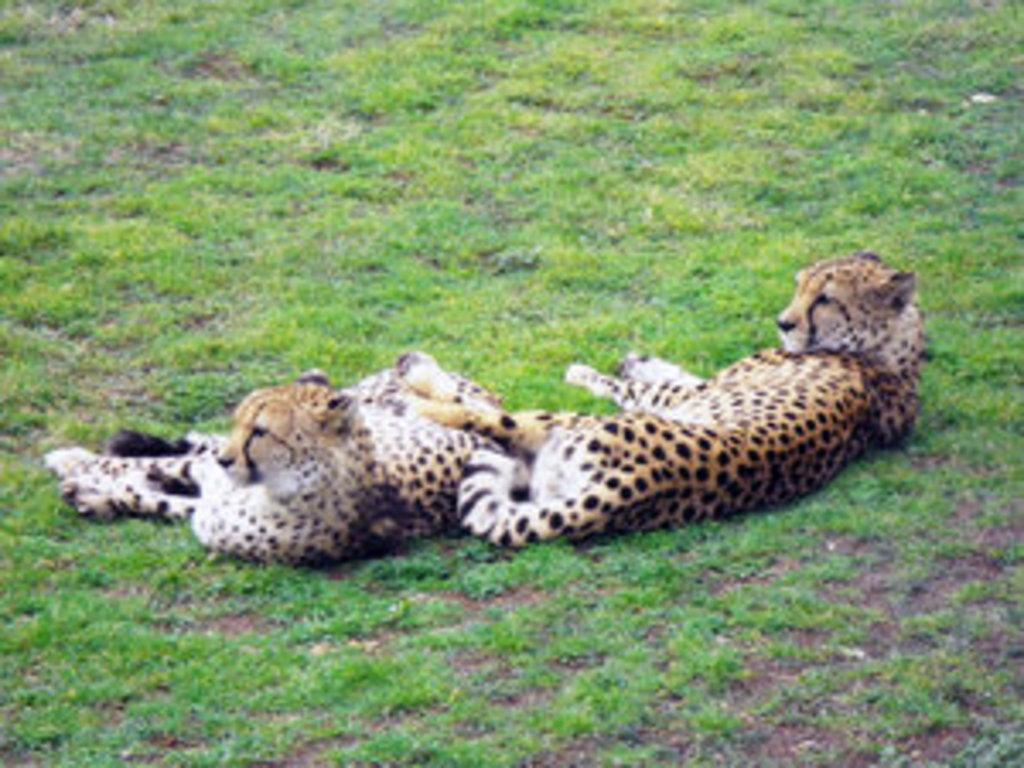What animals are in the center of the image? There are cheetahs in the center of the image. What type of vegetation can be seen in the image? There is grass visible in the image. What is the name of the cheetah's daughter in the image? There is no information about the cheetahs' names or family in the image. Can you see a tub in the image? There is no tub present in the image. 